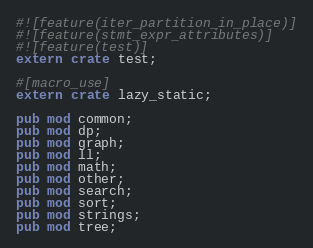Convert code to text. <code><loc_0><loc_0><loc_500><loc_500><_Rust_>#![feature(iter_partition_in_place)]
#![feature(stmt_expr_attributes)]
#![feature(test)]
extern crate test;

#[macro_use]
extern crate lazy_static;

pub mod common;
pub mod dp;
pub mod graph;
pub mod ll;
pub mod math;
pub mod other;
pub mod search;
pub mod sort;
pub mod strings;
pub mod tree;
</code> 